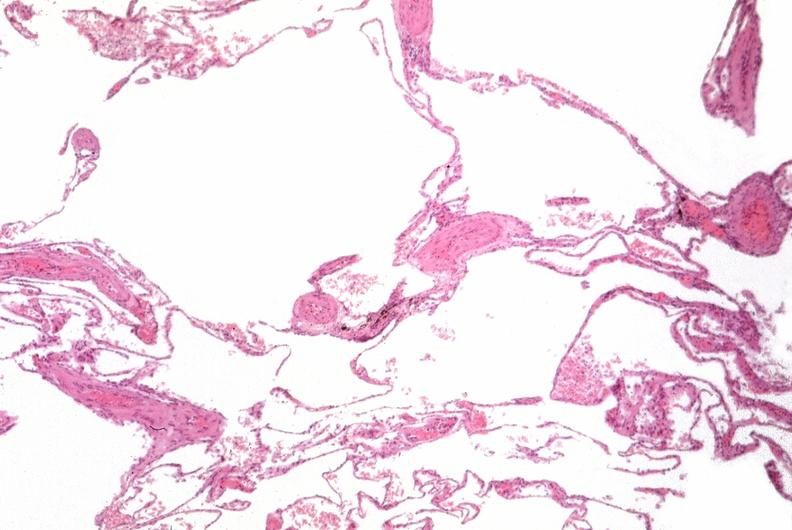what is present?
Answer the question using a single word or phrase. Respiratory 